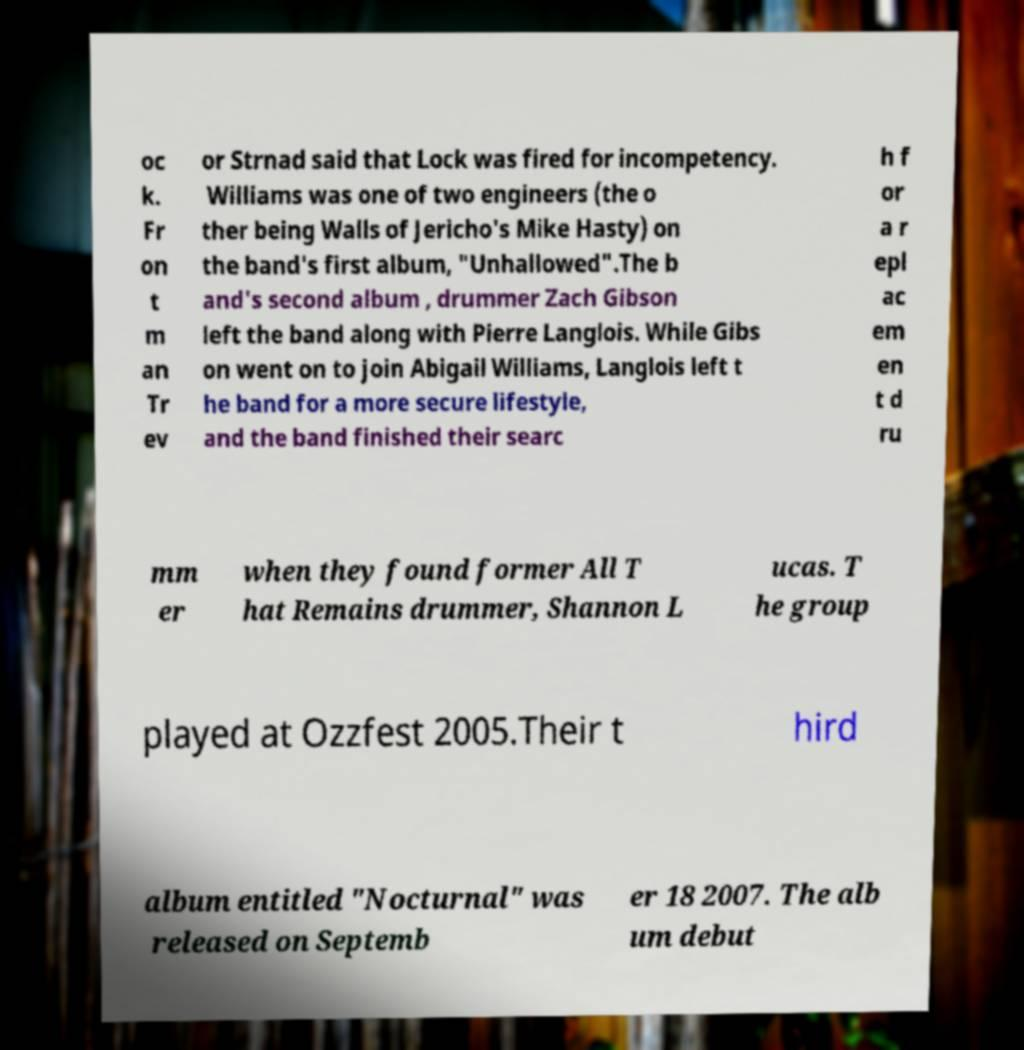There's text embedded in this image that I need extracted. Can you transcribe it verbatim? oc k. Fr on t m an Tr ev or Strnad said that Lock was fired for incompetency. Williams was one of two engineers (the o ther being Walls of Jericho's Mike Hasty) on the band's first album, "Unhallowed".The b and's second album , drummer Zach Gibson left the band along with Pierre Langlois. While Gibs on went on to join Abigail Williams, Langlois left t he band for a more secure lifestyle, and the band finished their searc h f or a r epl ac em en t d ru mm er when they found former All T hat Remains drummer, Shannon L ucas. T he group played at Ozzfest 2005.Their t hird album entitled "Nocturnal" was released on Septemb er 18 2007. The alb um debut 